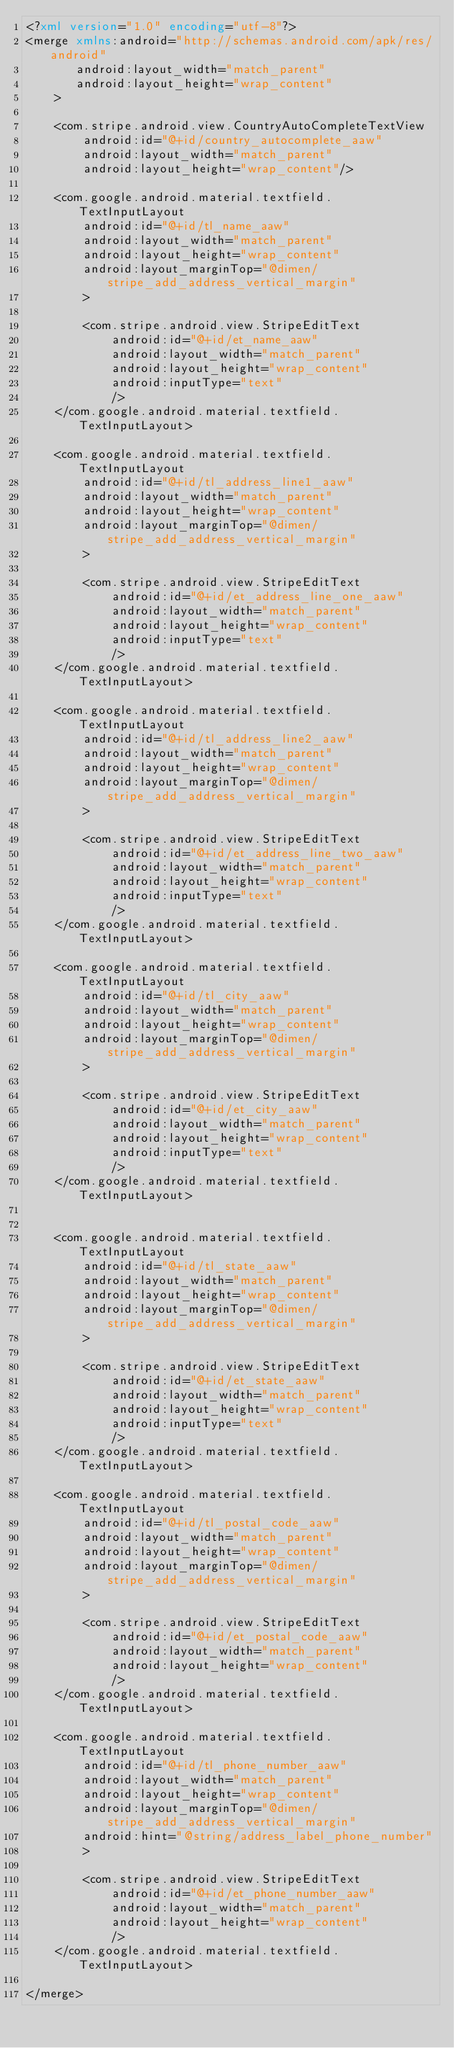Convert code to text. <code><loc_0><loc_0><loc_500><loc_500><_XML_><?xml version="1.0" encoding="utf-8"?>
<merge xmlns:android="http://schemas.android.com/apk/res/android"
       android:layout_width="match_parent"
       android:layout_height="wrap_content"
    >

    <com.stripe.android.view.CountryAutoCompleteTextView
        android:id="@+id/country_autocomplete_aaw"
        android:layout_width="match_parent"
        android:layout_height="wrap_content"/>

    <com.google.android.material.textfield.TextInputLayout
        android:id="@+id/tl_name_aaw"
        android:layout_width="match_parent"
        android:layout_height="wrap_content"
        android:layout_marginTop="@dimen/stripe_add_address_vertical_margin"
        >

        <com.stripe.android.view.StripeEditText
            android:id="@+id/et_name_aaw"
            android:layout_width="match_parent"
            android:layout_height="wrap_content"
            android:inputType="text"
            />
    </com.google.android.material.textfield.TextInputLayout>

    <com.google.android.material.textfield.TextInputLayout
        android:id="@+id/tl_address_line1_aaw"
        android:layout_width="match_parent"
        android:layout_height="wrap_content"
        android:layout_marginTop="@dimen/stripe_add_address_vertical_margin"
        >

        <com.stripe.android.view.StripeEditText
            android:id="@+id/et_address_line_one_aaw"
            android:layout_width="match_parent"
            android:layout_height="wrap_content"
            android:inputType="text"
            />
    </com.google.android.material.textfield.TextInputLayout>

    <com.google.android.material.textfield.TextInputLayout
        android:id="@+id/tl_address_line2_aaw"
        android:layout_width="match_parent"
        android:layout_height="wrap_content"
        android:layout_marginTop="@dimen/stripe_add_address_vertical_margin"
        >

        <com.stripe.android.view.StripeEditText
            android:id="@+id/et_address_line_two_aaw"
            android:layout_width="match_parent"
            android:layout_height="wrap_content"
            android:inputType="text"
            />
    </com.google.android.material.textfield.TextInputLayout>

    <com.google.android.material.textfield.TextInputLayout
        android:id="@+id/tl_city_aaw"
        android:layout_width="match_parent"
        android:layout_height="wrap_content"
        android:layout_marginTop="@dimen/stripe_add_address_vertical_margin"
        >

        <com.stripe.android.view.StripeEditText
            android:id="@+id/et_city_aaw"
            android:layout_width="match_parent"
            android:layout_height="wrap_content"
            android:inputType="text"
            />
    </com.google.android.material.textfield.TextInputLayout>


    <com.google.android.material.textfield.TextInputLayout
        android:id="@+id/tl_state_aaw"
        android:layout_width="match_parent"
        android:layout_height="wrap_content"
        android:layout_marginTop="@dimen/stripe_add_address_vertical_margin"
        >

        <com.stripe.android.view.StripeEditText
            android:id="@+id/et_state_aaw"
            android:layout_width="match_parent"
            android:layout_height="wrap_content"
            android:inputType="text"
            />
    </com.google.android.material.textfield.TextInputLayout>

    <com.google.android.material.textfield.TextInputLayout
        android:id="@+id/tl_postal_code_aaw"
        android:layout_width="match_parent"
        android:layout_height="wrap_content"
        android:layout_marginTop="@dimen/stripe_add_address_vertical_margin"
        >

        <com.stripe.android.view.StripeEditText
            android:id="@+id/et_postal_code_aaw"
            android:layout_width="match_parent"
            android:layout_height="wrap_content"
            />
    </com.google.android.material.textfield.TextInputLayout>

    <com.google.android.material.textfield.TextInputLayout
        android:id="@+id/tl_phone_number_aaw"
        android:layout_width="match_parent"
        android:layout_height="wrap_content"
        android:layout_marginTop="@dimen/stripe_add_address_vertical_margin"
        android:hint="@string/address_label_phone_number"
        >

        <com.stripe.android.view.StripeEditText
            android:id="@+id/et_phone_number_aaw"
            android:layout_width="match_parent"
            android:layout_height="wrap_content"
            />
    </com.google.android.material.textfield.TextInputLayout>

</merge>
</code> 